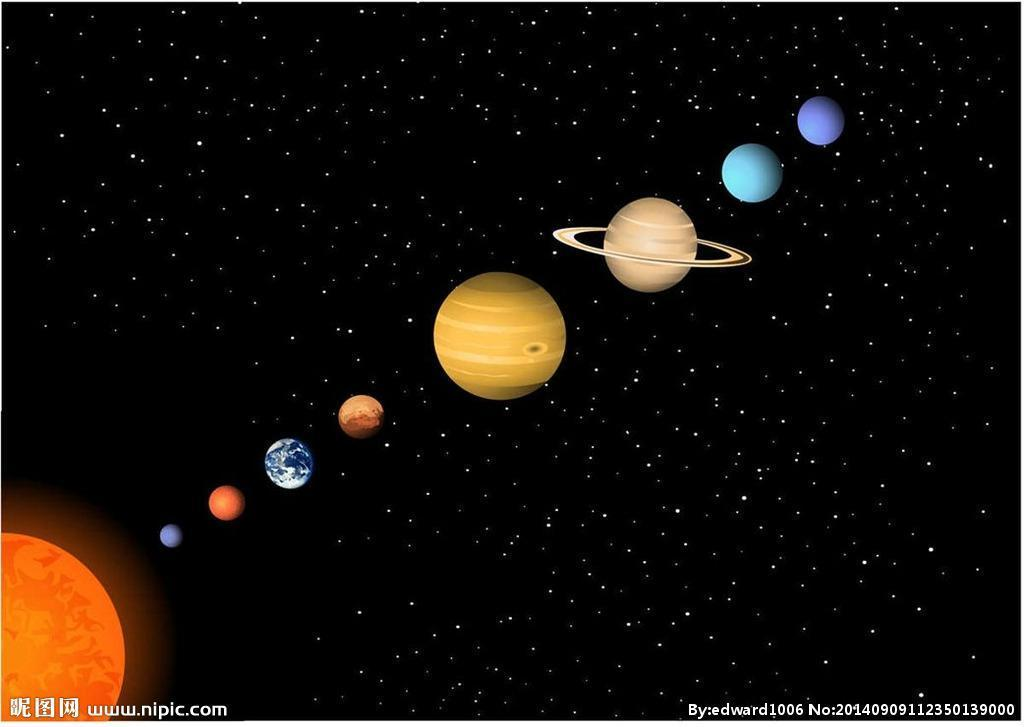What is the position of Jupiter in the picture and what color is it Jupiter is the large, yellow planet in the middle of the image with rings around it.  It is to the right of the center of the picture. 